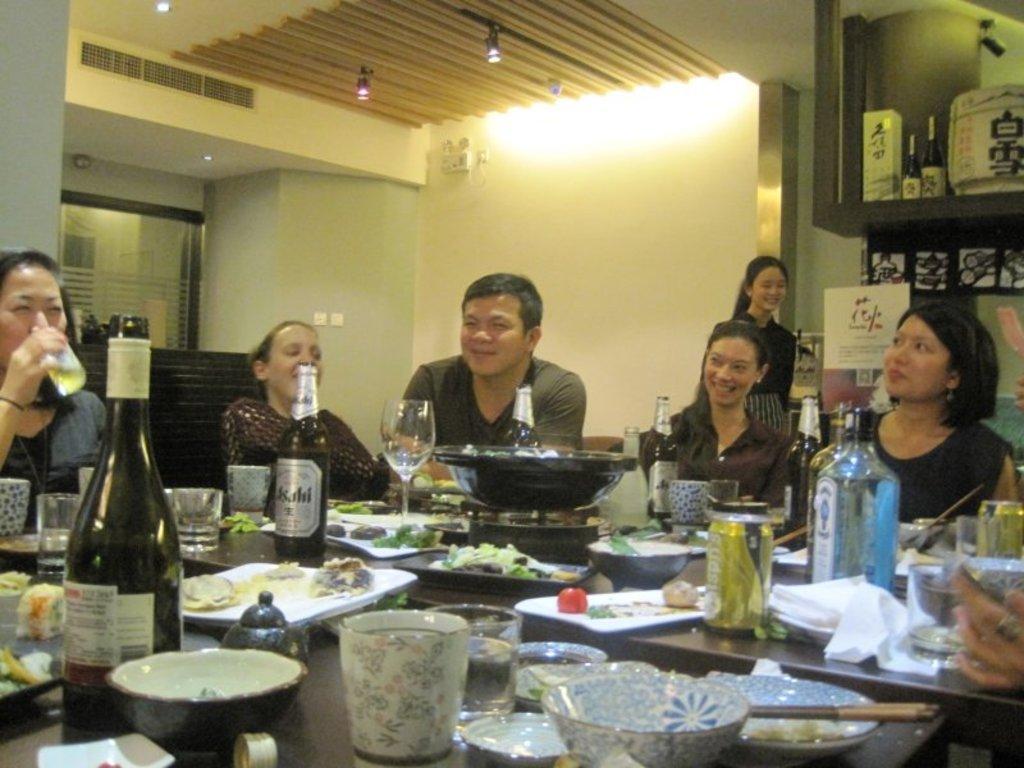Can you describe this image briefly? In this image i can see few people sitting on chairs around the dining table, a woman on the left corner is holding a glass in her hand. On the table i can see few bowls, few plates, few chopsticks, few bottles, few glasses and few food items. In the background i can see the wall, the ceiling, few switch boards, a woman standing and few shelves in which there are few bottles and few other objects. 